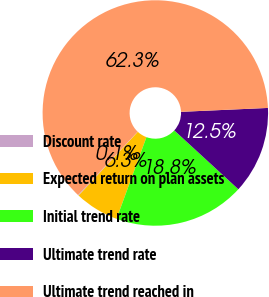<chart> <loc_0><loc_0><loc_500><loc_500><pie_chart><fcel>Discount rate<fcel>Expected return on plan assets<fcel>Initial trend rate<fcel>Ultimate trend rate<fcel>Ultimate trend reached in<nl><fcel>0.11%<fcel>6.33%<fcel>18.76%<fcel>12.54%<fcel>62.26%<nl></chart> 